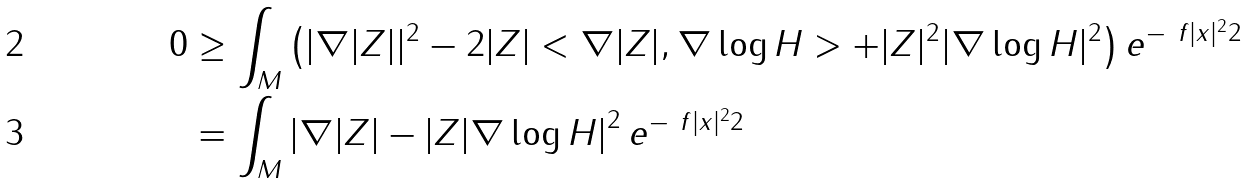Convert formula to latex. <formula><loc_0><loc_0><loc_500><loc_500>0 & \geq \int _ { M } \left ( | \nabla | Z | | ^ { 2 } - 2 | Z | < \nabla | Z | , \nabla \log H > + | Z | ^ { 2 } | \nabla \log H | ^ { 2 } \right ) e ^ { - \ f { | x | ^ { 2 } } { 2 } } \\ & = \int _ { M } \left | \nabla | Z | - | Z | \nabla \log H \right | ^ { 2 } e ^ { - \ f { | x | ^ { 2 } } { 2 } }</formula> 